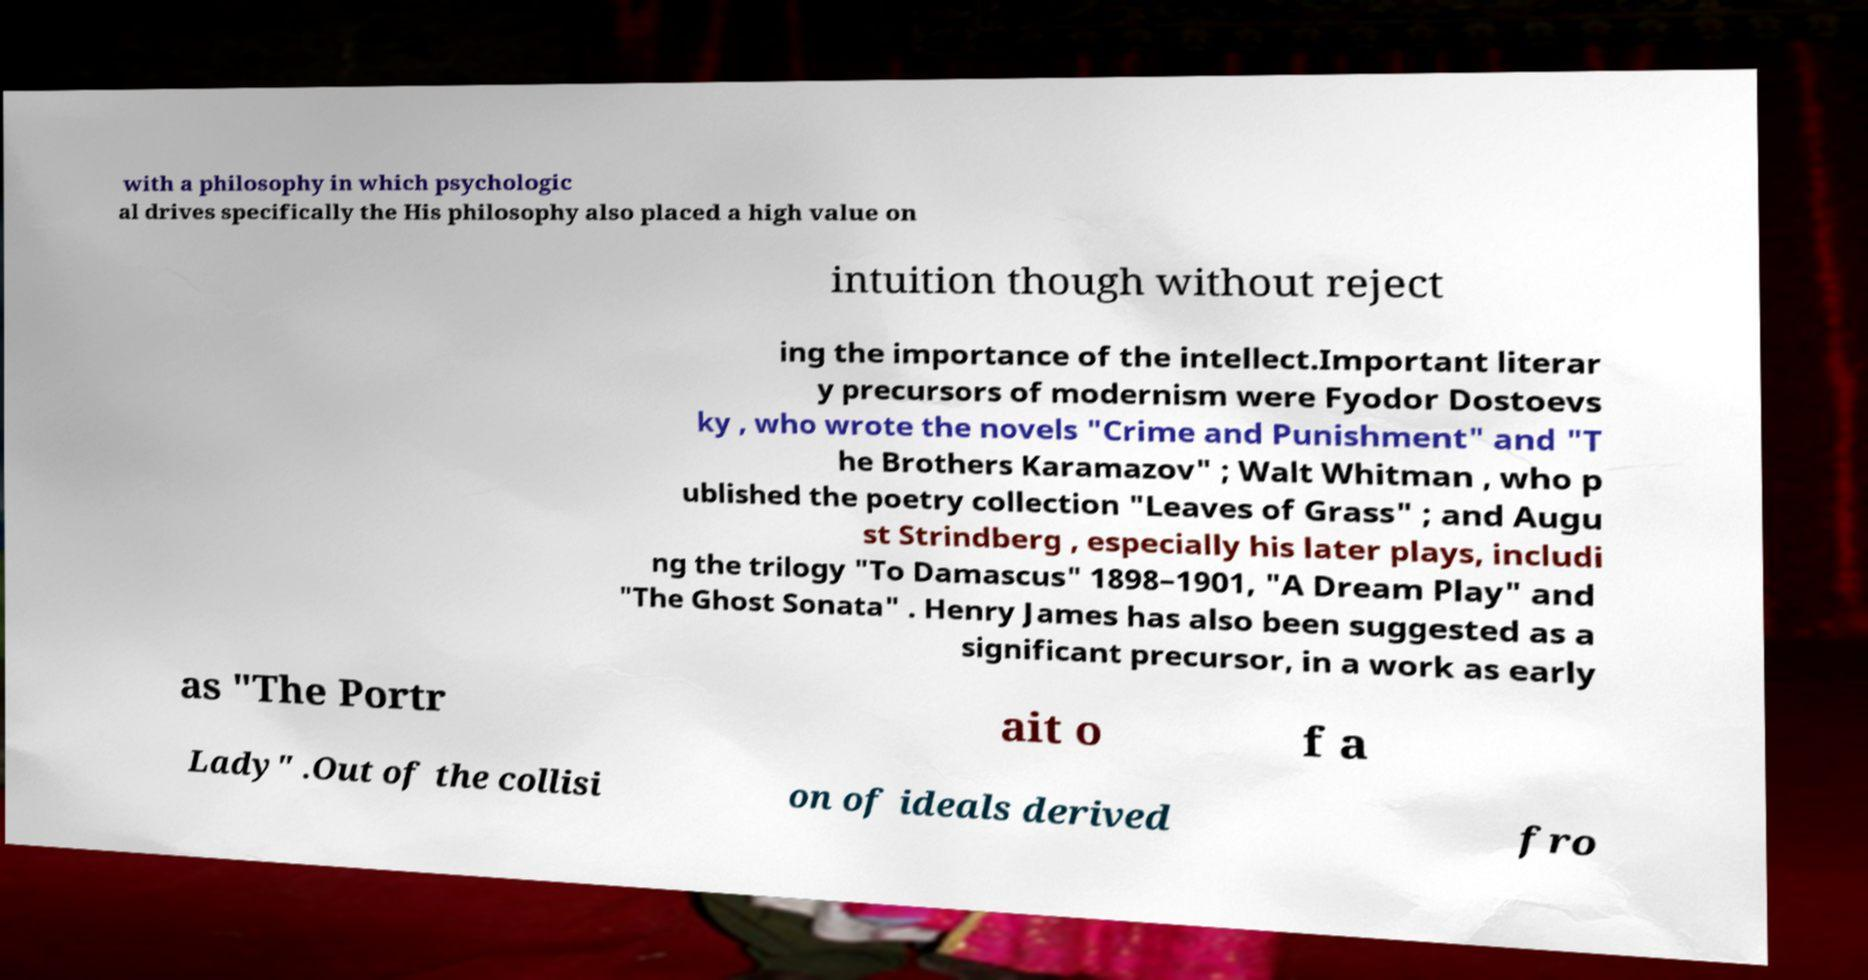Please read and relay the text visible in this image. What does it say? with a philosophy in which psychologic al drives specifically the His philosophy also placed a high value on intuition though without reject ing the importance of the intellect.Important literar y precursors of modernism were Fyodor Dostoevs ky , who wrote the novels "Crime and Punishment" and "T he Brothers Karamazov" ; Walt Whitman , who p ublished the poetry collection "Leaves of Grass" ; and Augu st Strindberg , especially his later plays, includi ng the trilogy "To Damascus" 1898–1901, "A Dream Play" and "The Ghost Sonata" . Henry James has also been suggested as a significant precursor, in a work as early as "The Portr ait o f a Lady" .Out of the collisi on of ideals derived fro 